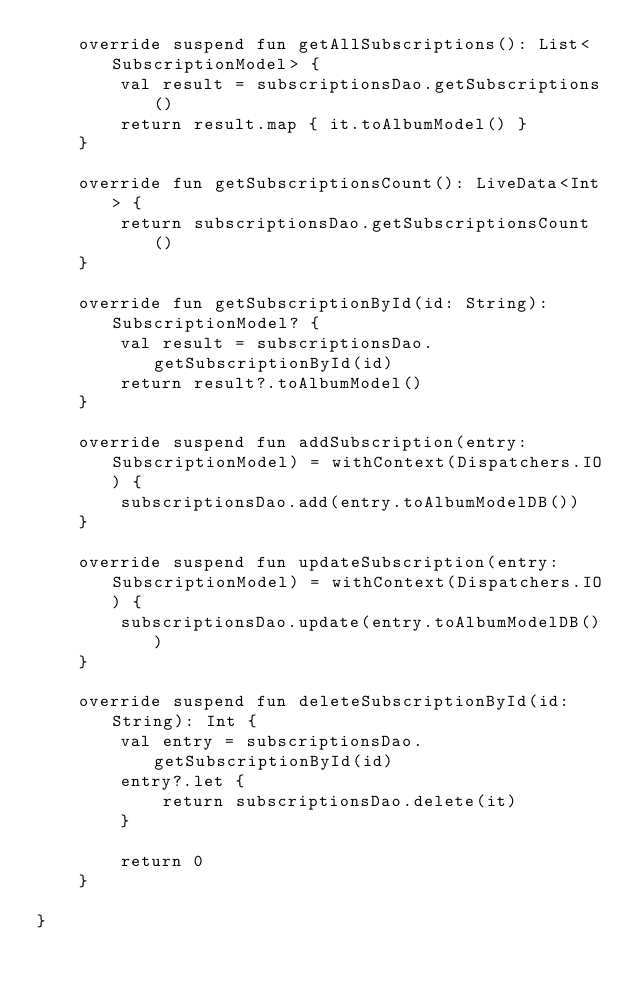Convert code to text. <code><loc_0><loc_0><loc_500><loc_500><_Kotlin_>    override suspend fun getAllSubscriptions(): List<SubscriptionModel> {
        val result = subscriptionsDao.getSubscriptions()
        return result.map { it.toAlbumModel() }
    }

    override fun getSubscriptionsCount(): LiveData<Int> {
        return subscriptionsDao.getSubscriptionsCount()
    }

    override fun getSubscriptionById(id: String): SubscriptionModel? {
        val result = subscriptionsDao.getSubscriptionById(id)
        return result?.toAlbumModel()
    }

    override suspend fun addSubscription(entry: SubscriptionModel) = withContext(Dispatchers.IO) {
        subscriptionsDao.add(entry.toAlbumModelDB())
    }

    override suspend fun updateSubscription(entry: SubscriptionModel) = withContext(Dispatchers.IO) {
        subscriptionsDao.update(entry.toAlbumModelDB())
    }

    override suspend fun deleteSubscriptionById(id: String): Int {
        val entry = subscriptionsDao.getSubscriptionById(id)
        entry?.let {
            return subscriptionsDao.delete(it)
        }
        
        return 0
    }

}</code> 